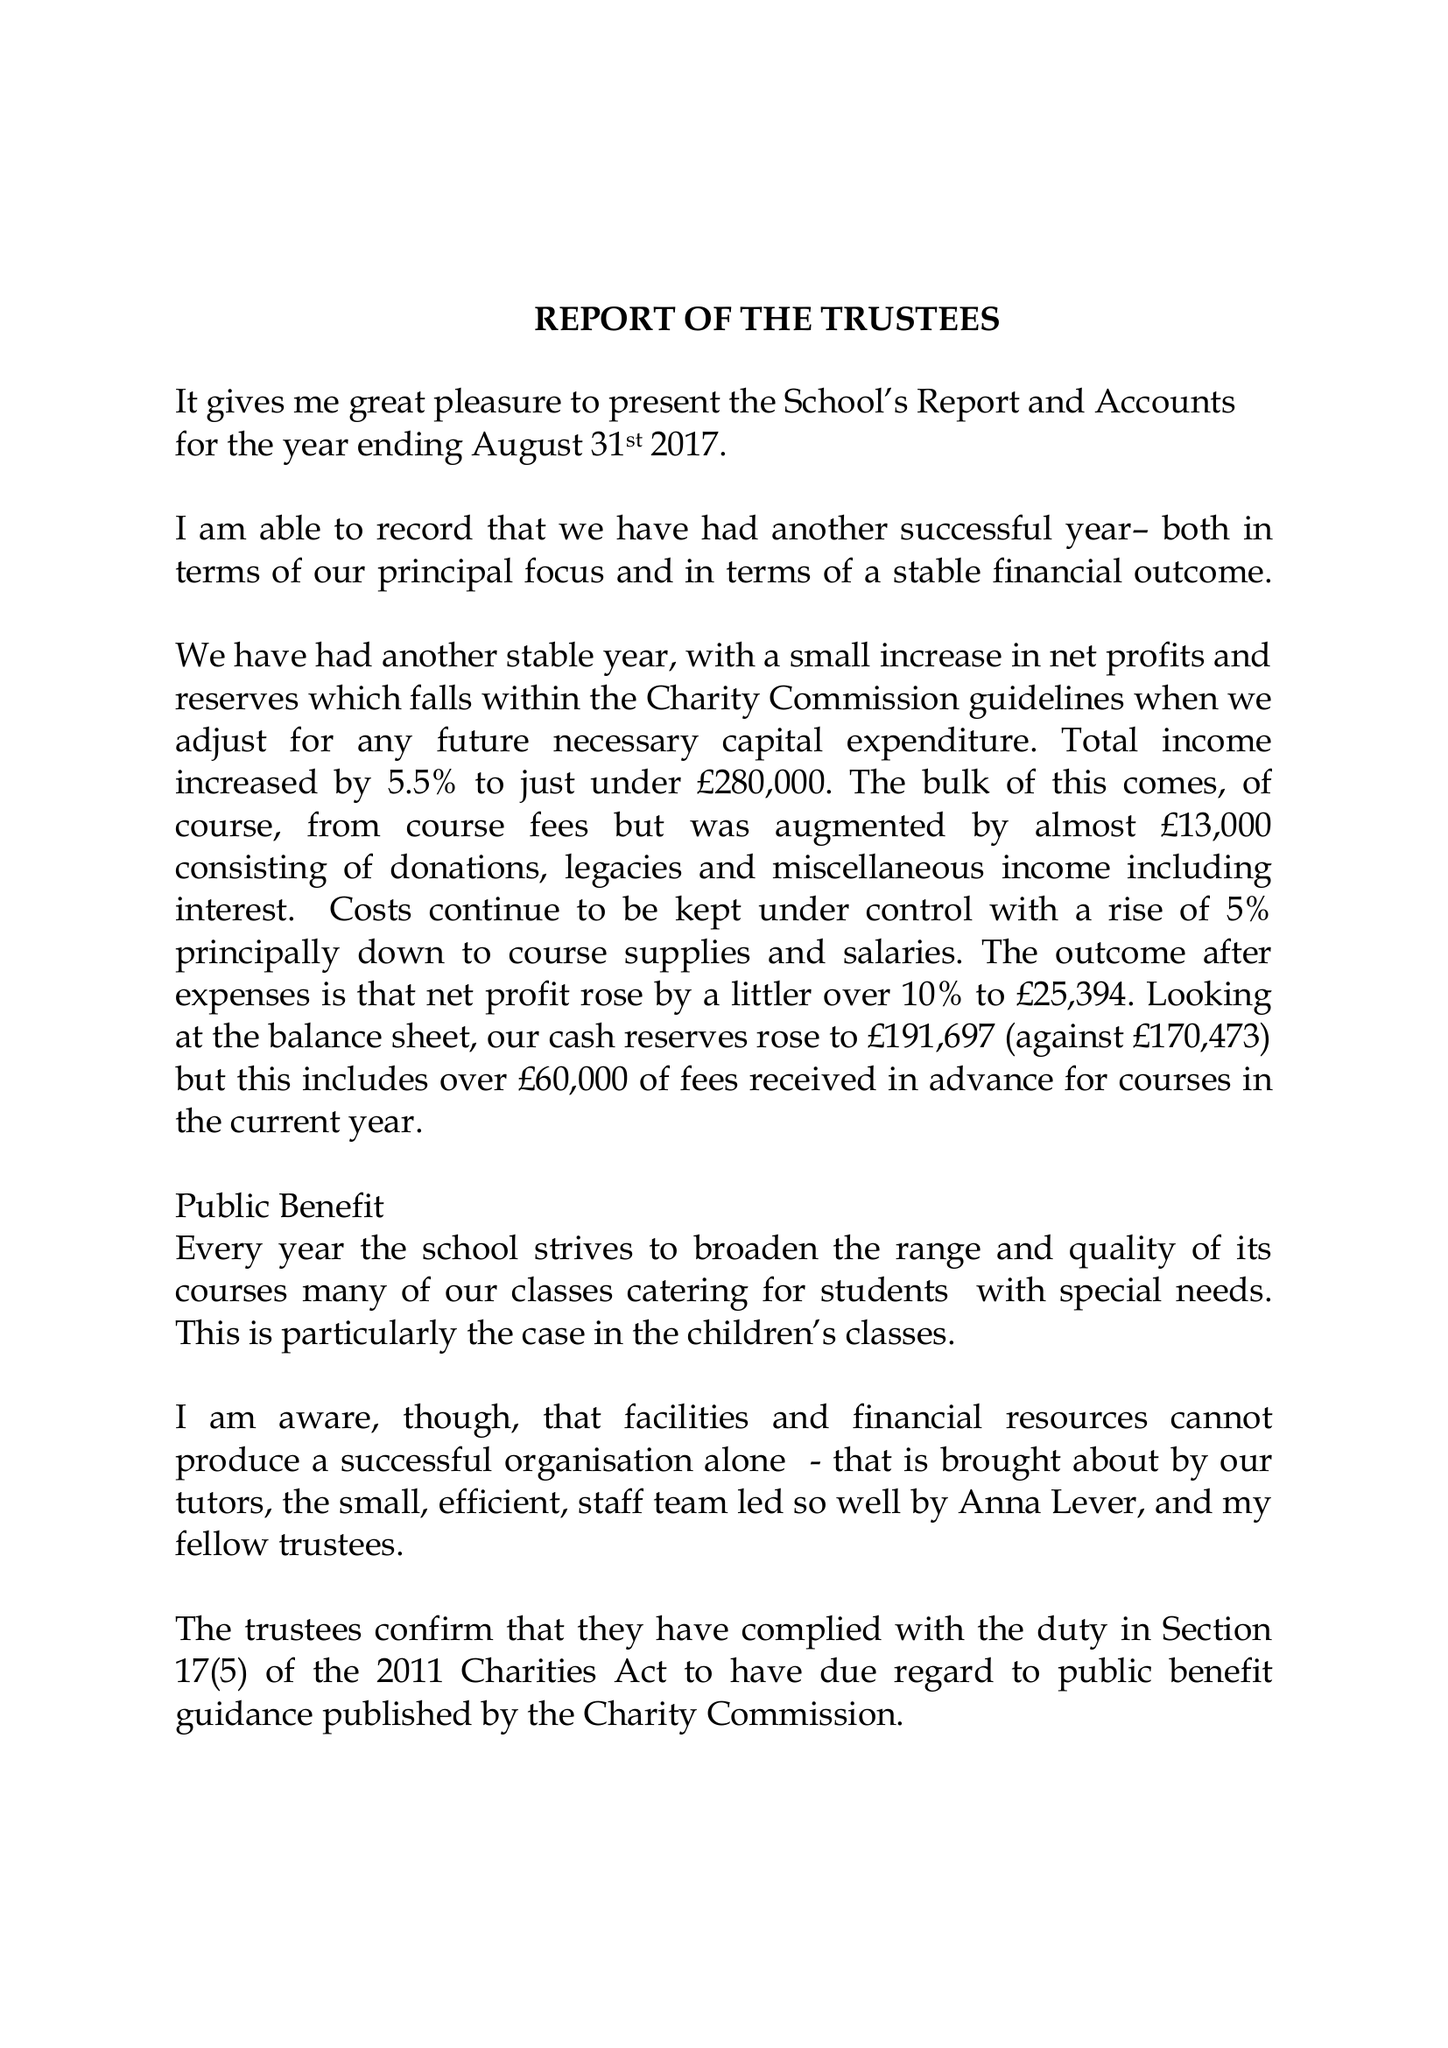What is the value for the charity_name?
Answer the question using a single word or phrase. The Sunningwell School Of Art 